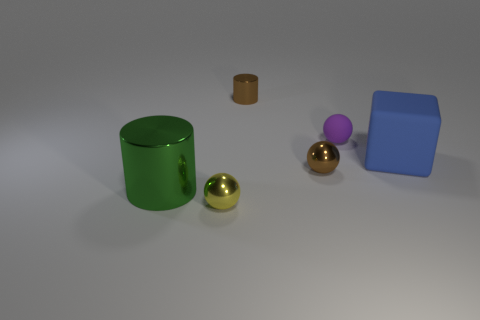Subtract all yellow metal spheres. How many spheres are left? 2 Subtract all brown balls. How many balls are left? 2 Subtract all blocks. How many objects are left? 5 Add 4 big gray matte cubes. How many objects exist? 10 Add 6 tiny matte things. How many tiny matte things are left? 7 Add 6 tiny rubber things. How many tiny rubber things exist? 7 Subtract 0 blue cylinders. How many objects are left? 6 Subtract 1 spheres. How many spheres are left? 2 Subtract all brown cubes. Subtract all green cylinders. How many cubes are left? 1 Subtract all gray cubes. How many yellow spheres are left? 1 